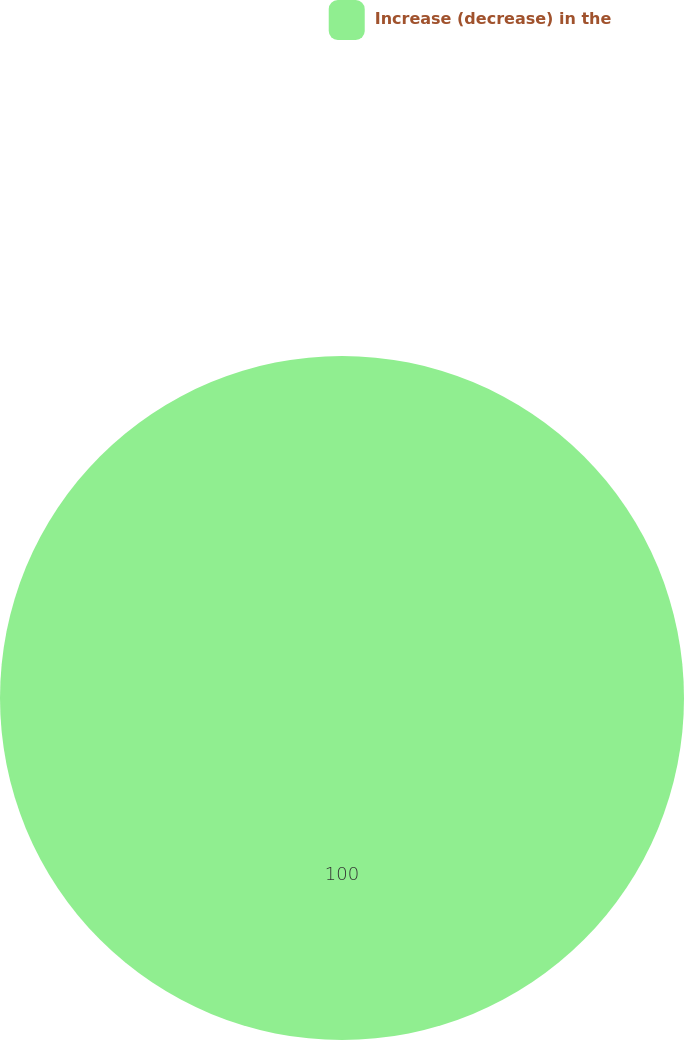Convert chart. <chart><loc_0><loc_0><loc_500><loc_500><pie_chart><fcel>Increase (decrease) in the<nl><fcel>100.0%<nl></chart> 